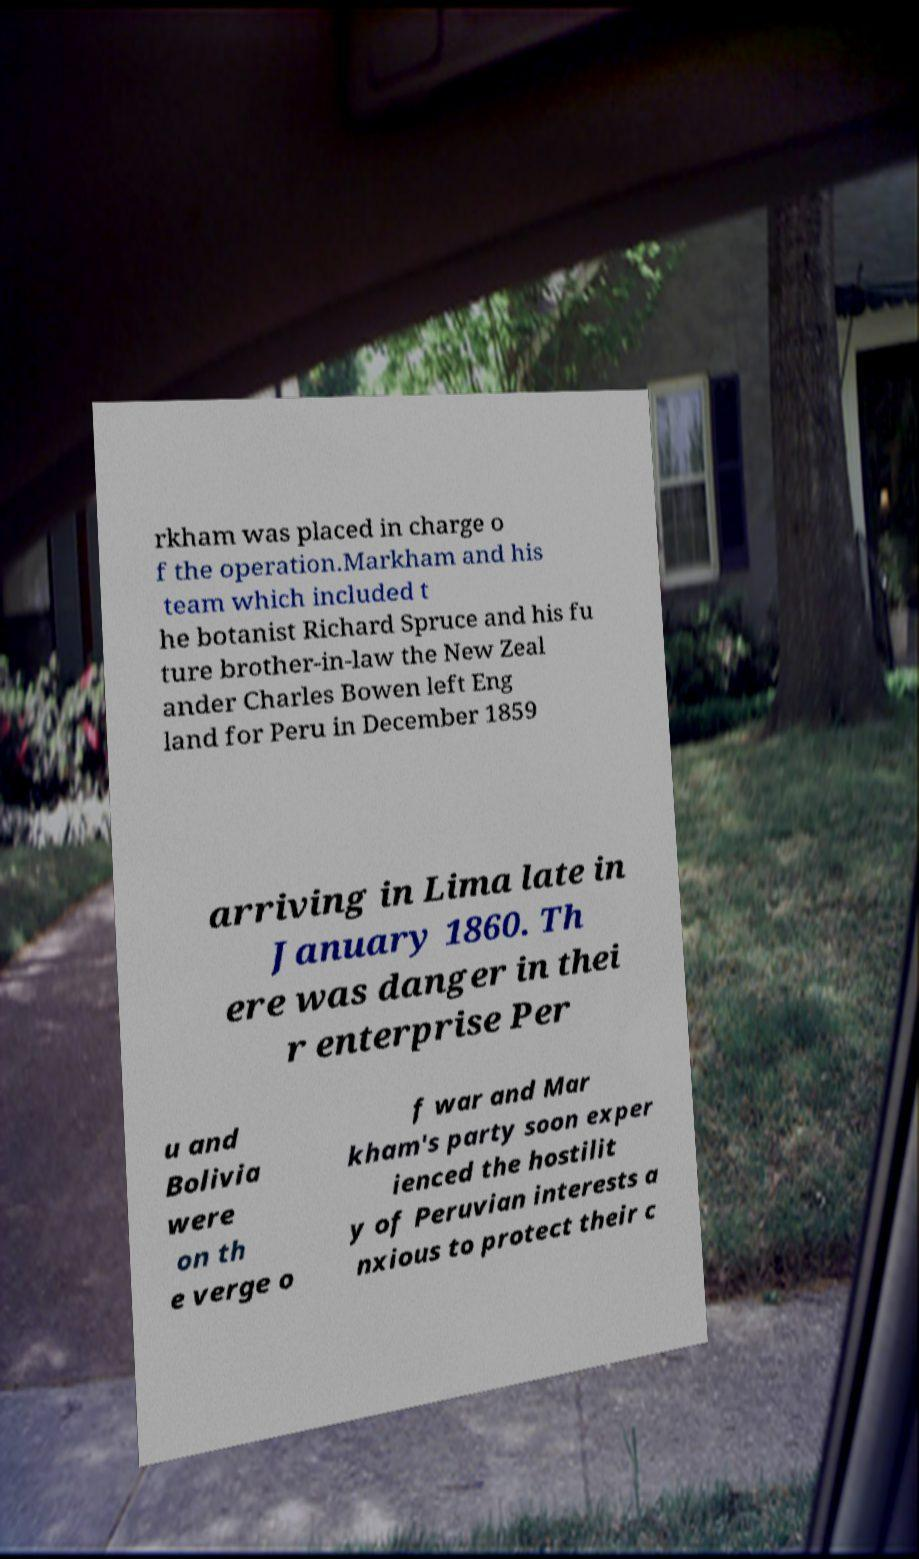I need the written content from this picture converted into text. Can you do that? rkham was placed in charge o f the operation.Markham and his team which included t he botanist Richard Spruce and his fu ture brother-in-law the New Zeal ander Charles Bowen left Eng land for Peru in December 1859 arriving in Lima late in January 1860. Th ere was danger in thei r enterprise Per u and Bolivia were on th e verge o f war and Mar kham's party soon exper ienced the hostilit y of Peruvian interests a nxious to protect their c 